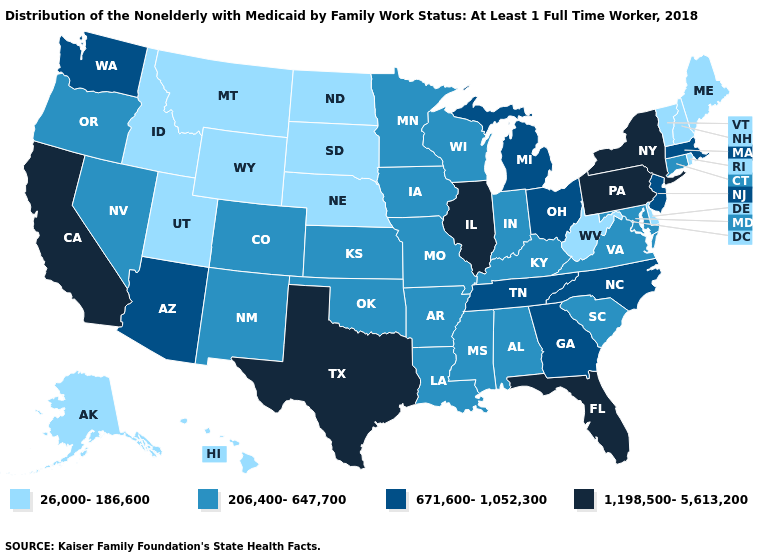What is the value of California?
Write a very short answer. 1,198,500-5,613,200. Does the first symbol in the legend represent the smallest category?
Concise answer only. Yes. Among the states that border Montana , which have the lowest value?
Short answer required. Idaho, North Dakota, South Dakota, Wyoming. Name the states that have a value in the range 26,000-186,600?
Short answer required. Alaska, Delaware, Hawaii, Idaho, Maine, Montana, Nebraska, New Hampshire, North Dakota, Rhode Island, South Dakota, Utah, Vermont, West Virginia, Wyoming. Name the states that have a value in the range 1,198,500-5,613,200?
Write a very short answer. California, Florida, Illinois, New York, Pennsylvania, Texas. What is the value of Mississippi?
Answer briefly. 206,400-647,700. Which states have the highest value in the USA?
Concise answer only. California, Florida, Illinois, New York, Pennsylvania, Texas. Among the states that border Connecticut , does New York have the highest value?
Give a very brief answer. Yes. Name the states that have a value in the range 1,198,500-5,613,200?
Give a very brief answer. California, Florida, Illinois, New York, Pennsylvania, Texas. What is the lowest value in the USA?
Be succinct. 26,000-186,600. What is the value of Maine?
Give a very brief answer. 26,000-186,600. Name the states that have a value in the range 26,000-186,600?
Short answer required. Alaska, Delaware, Hawaii, Idaho, Maine, Montana, Nebraska, New Hampshire, North Dakota, Rhode Island, South Dakota, Utah, Vermont, West Virginia, Wyoming. What is the value of North Dakota?
Be succinct. 26,000-186,600. Does Nebraska have the lowest value in the MidWest?
Short answer required. Yes. Which states have the lowest value in the Northeast?
Be succinct. Maine, New Hampshire, Rhode Island, Vermont. 